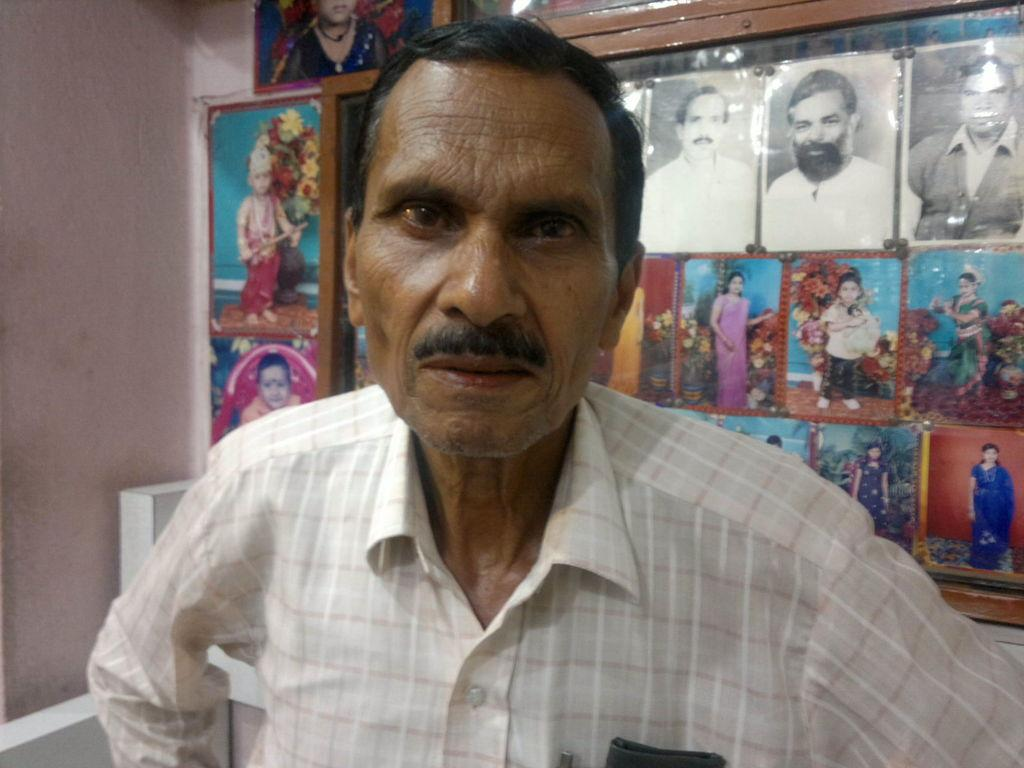What is the man in the image wearing? The man in the image is wearing a white checkered shirt. What can be seen on the wall behind the man? There are many photos in frames on the wall behind the man. What color is the wall visible to the left side of the image? The wall visible to the left side of the image is pink. What type of fog can be seen in the image? There is no fog present in the image. 